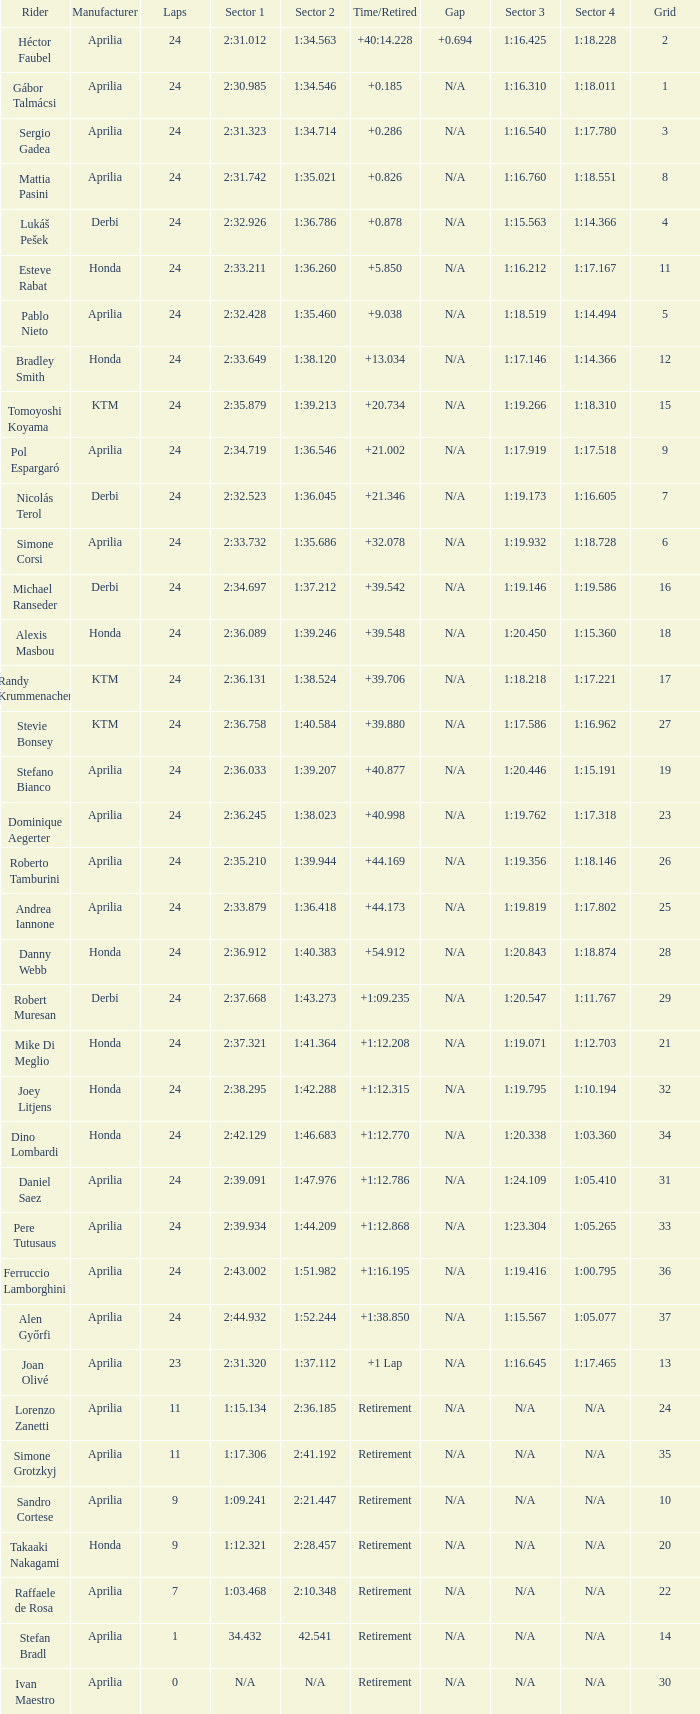Who manufactured the motorcycle that did 24 laps and 9 grids? Aprilia. 